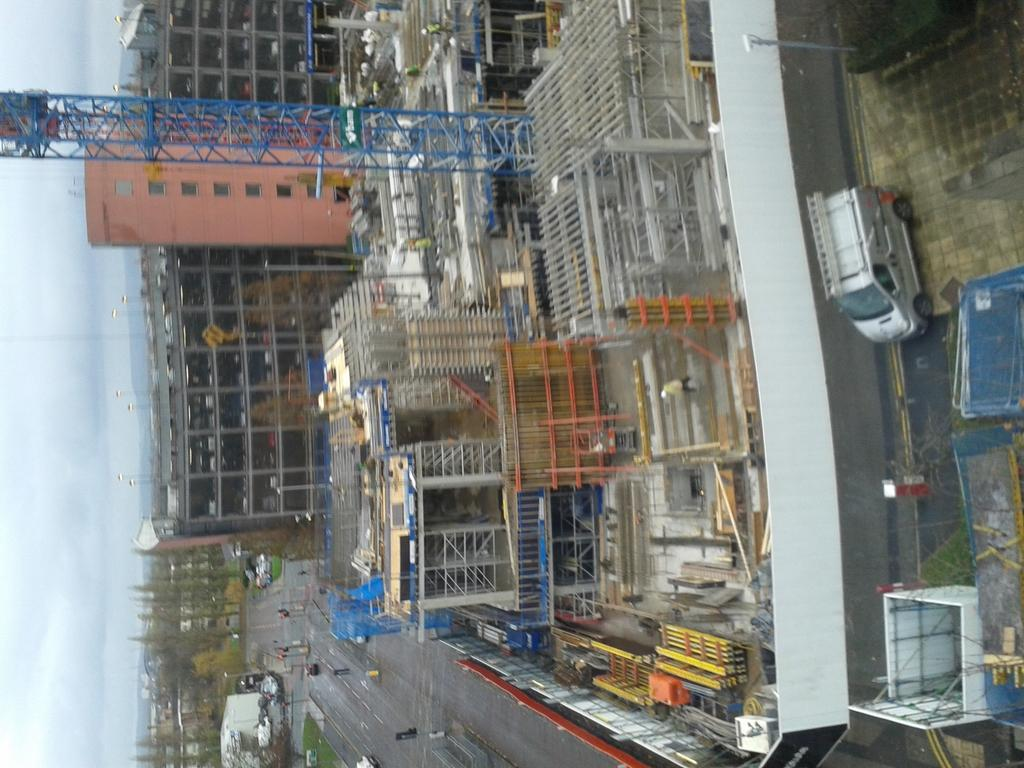What type of structures can be seen in the image? There are buildings in the image. What is the main feature of the landscape in the image? There is a road in the image. What type of transportation is visible in the image? There are vehicles in the image. What are the poles used for in the image? The poles are likely used for supporting traffic signals or other infrastructure. What can be seen in the sky in the image? The sky is visible in the image, and clouds are present in the sky. Can you see any cattle grazing on the side of the road in the image? There is no cattle visible in the image; it features buildings, a road, vehicles, poles, traffic signals, and a sky with clouds. Is there a person wearing a scarf in the image? There is no person wearing a scarf in the image. 